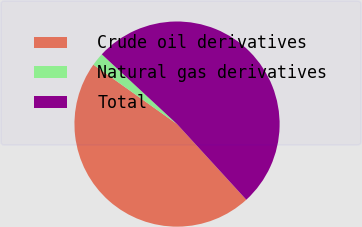Convert chart to OTSL. <chart><loc_0><loc_0><loc_500><loc_500><pie_chart><fcel>Crude oil derivatives<fcel>Natural gas derivatives<fcel>Total<nl><fcel>46.63%<fcel>2.07%<fcel>51.3%<nl></chart> 